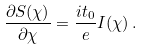Convert formula to latex. <formula><loc_0><loc_0><loc_500><loc_500>\frac { \partial S ( \chi ) } { \partial \chi } = \frac { i t _ { 0 } } { e } I ( \chi ) \, .</formula> 